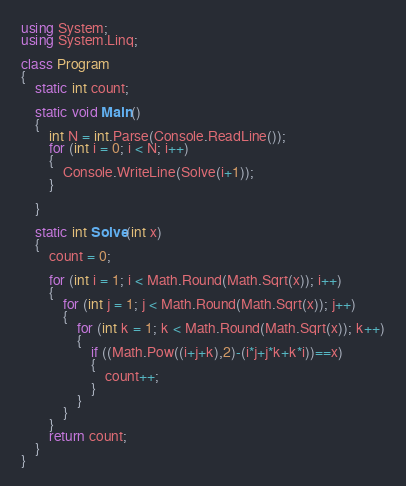<code> <loc_0><loc_0><loc_500><loc_500><_C#_>using System;
using System.Linq;

class Program
{
    static int count;

    static void Main()
    {
        int N = int.Parse(Console.ReadLine());
        for (int i = 0; i < N; i++)
        {
            Console.WriteLine(Solve(i+1));
        }
        
    }

    static int Solve(int x)
    {
        count = 0;

        for (int i = 1; i < Math.Round(Math.Sqrt(x)); i++)
        {
            for (int j = 1; j < Math.Round(Math.Sqrt(x)); j++)
            {
                for (int k = 1; k < Math.Round(Math.Sqrt(x)); k++)
                {
                    if ((Math.Pow((i+j+k),2)-(i*j+j*k+k*i))==x)
                    {
                        count++;
                    }
                }
            }
        }
        return count;
    }
}</code> 